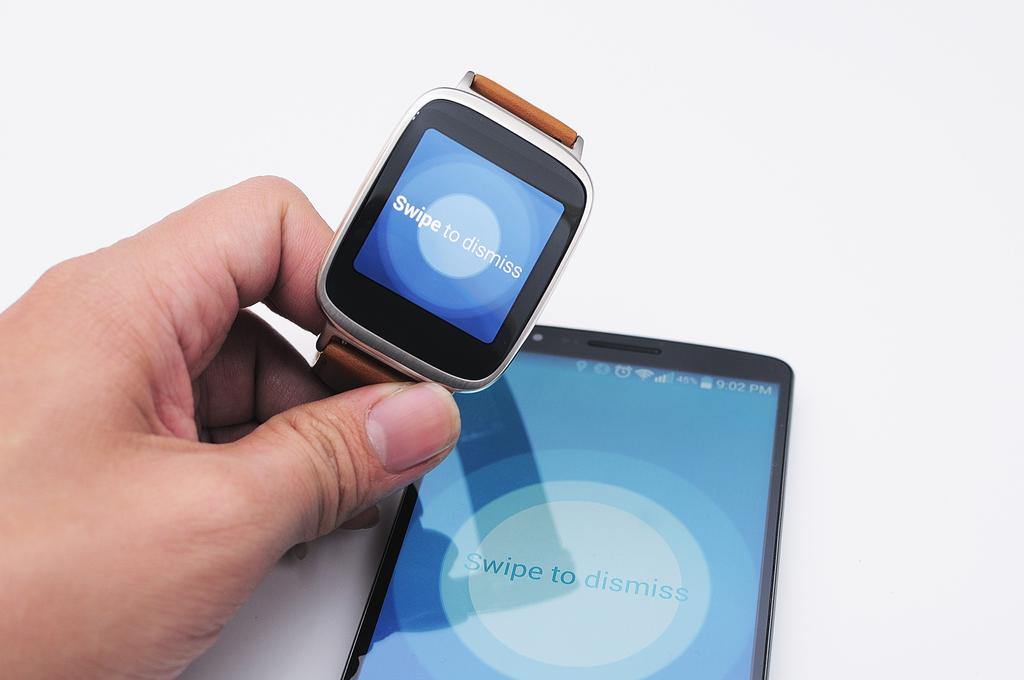What is being held in the person's hand in the image? There is a person's hand holding a watch in the image. What else can be seen in the image besides the hand and watch? There is a mobile on a platform in the image. What type of pancake is being served for the meal in the image? There is no pancake or meal present in the image; it only features a hand holding a watch and a mobile on a platform. 